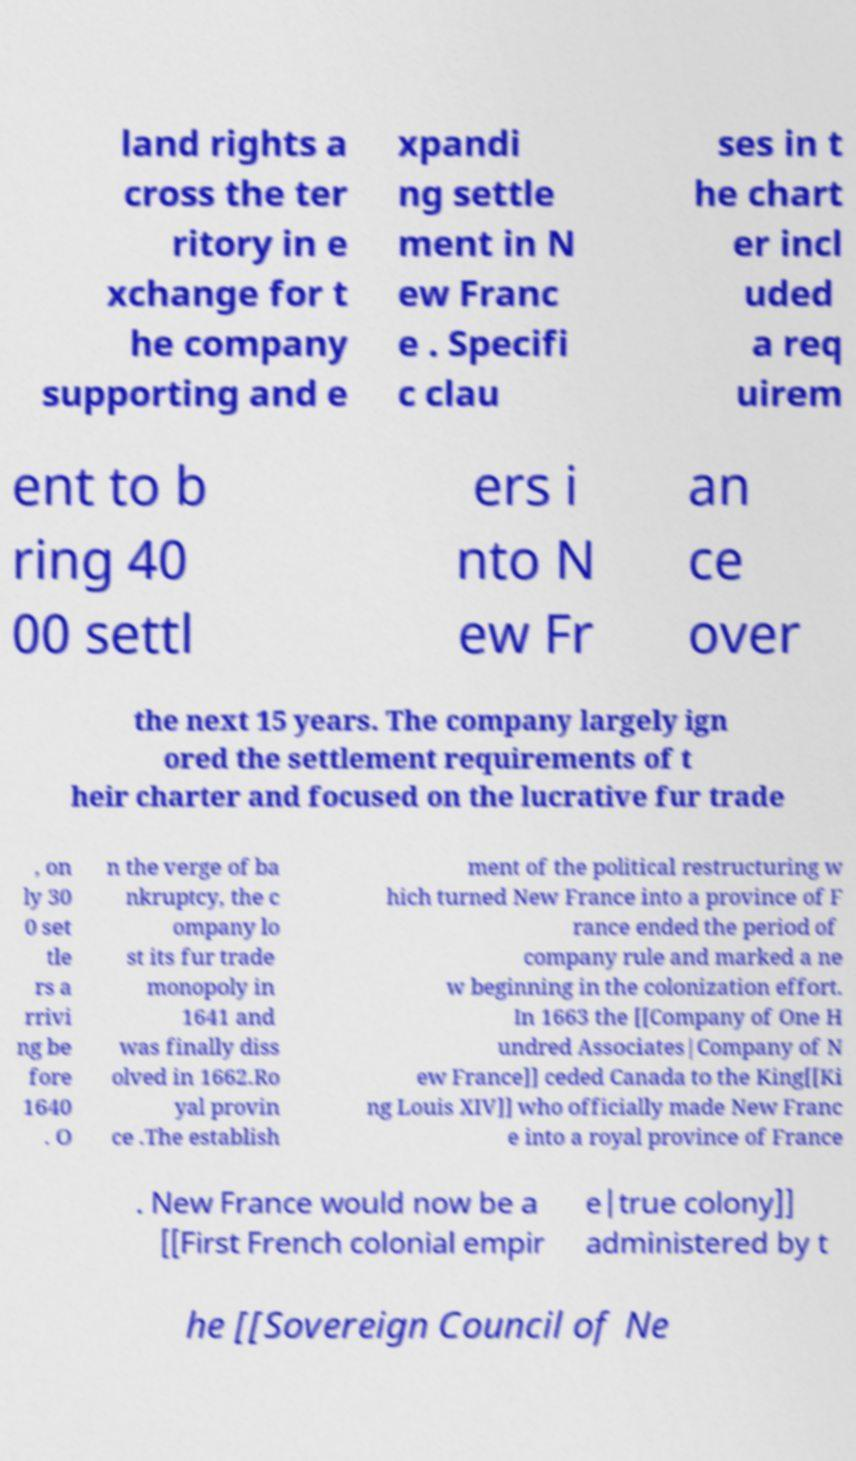Could you assist in decoding the text presented in this image and type it out clearly? land rights a cross the ter ritory in e xchange for t he company supporting and e xpandi ng settle ment in N ew Franc e . Specifi c clau ses in t he chart er incl uded a req uirem ent to b ring 40 00 settl ers i nto N ew Fr an ce over the next 15 years. The company largely ign ored the settlement requirements of t heir charter and focused on the lucrative fur trade , on ly 30 0 set tle rs a rrivi ng be fore 1640 . O n the verge of ba nkruptcy, the c ompany lo st its fur trade monopoly in 1641 and was finally diss olved in 1662.Ro yal provin ce .The establish ment of the political restructuring w hich turned New France into a province of F rance ended the period of company rule and marked a ne w beginning in the colonization effort. In 1663 the [[Company of One H undred Associates|Company of N ew France]] ceded Canada to the King[[Ki ng Louis XIV]] who officially made New Franc e into a royal province of France . New France would now be a [[First French colonial empir e|true colony]] administered by t he [[Sovereign Council of Ne 